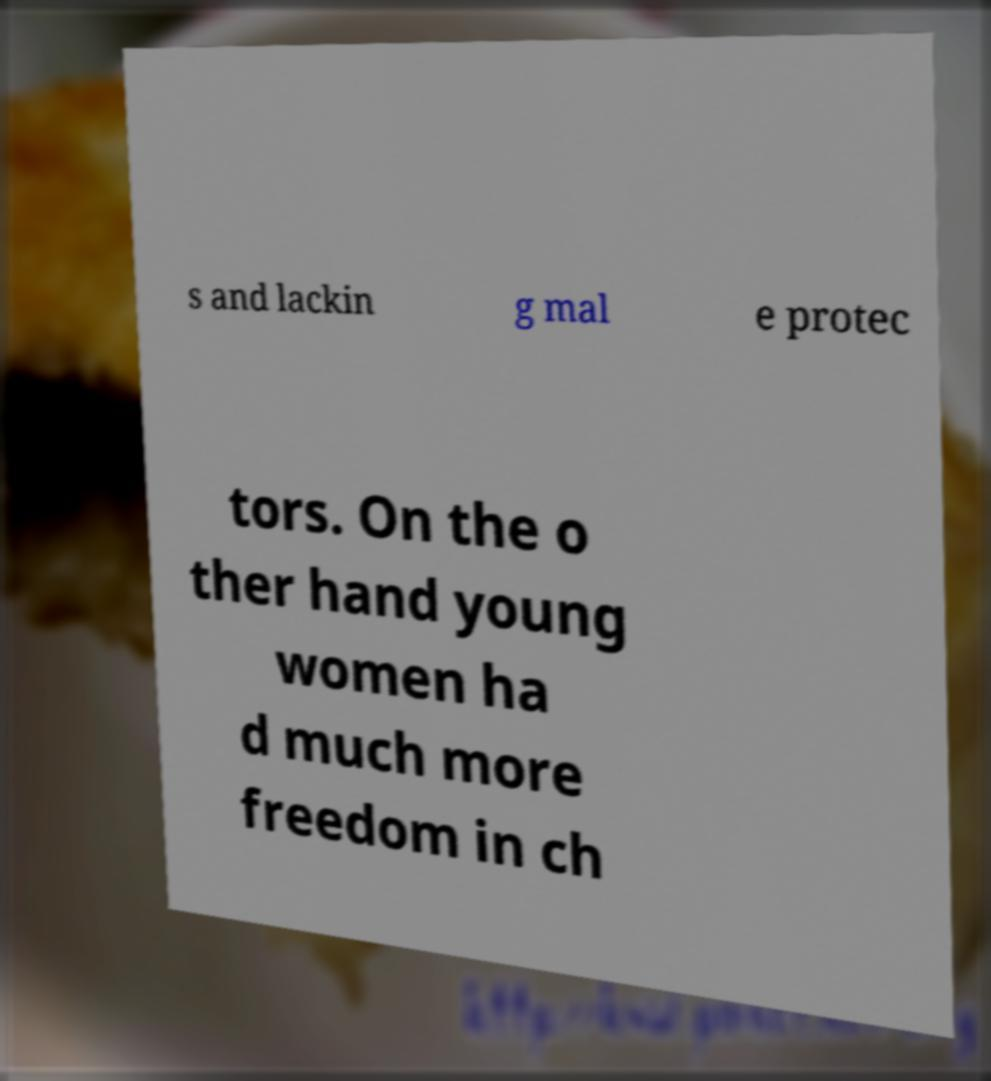Could you assist in decoding the text presented in this image and type it out clearly? s and lackin g mal e protec tors. On the o ther hand young women ha d much more freedom in ch 